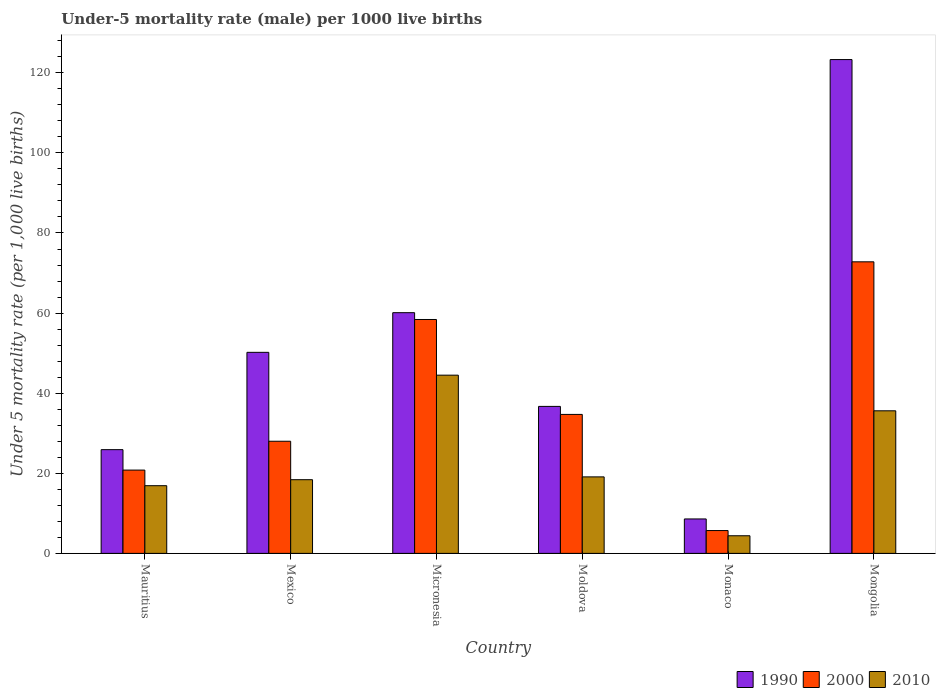Are the number of bars per tick equal to the number of legend labels?
Keep it short and to the point. Yes. How many bars are there on the 6th tick from the left?
Make the answer very short. 3. What is the label of the 4th group of bars from the left?
Give a very brief answer. Moldova. What is the under-five mortality rate in 1990 in Mongolia?
Give a very brief answer. 123.3. Across all countries, what is the maximum under-five mortality rate in 2000?
Provide a succinct answer. 72.8. In which country was the under-five mortality rate in 2010 maximum?
Make the answer very short. Micronesia. In which country was the under-five mortality rate in 2010 minimum?
Provide a short and direct response. Monaco. What is the total under-five mortality rate in 1990 in the graph?
Give a very brief answer. 304.8. What is the difference between the under-five mortality rate in 2010 in Mauritius and that in Monaco?
Provide a succinct answer. 12.5. What is the difference between the under-five mortality rate in 2000 in Mexico and the under-five mortality rate in 2010 in Micronesia?
Your response must be concise. -16.5. What is the average under-five mortality rate in 2000 per country?
Your response must be concise. 36.73. What is the difference between the under-five mortality rate of/in 2000 and under-five mortality rate of/in 2010 in Mexico?
Your response must be concise. 9.6. What is the ratio of the under-five mortality rate in 1990 in Mauritius to that in Mexico?
Provide a short and direct response. 0.52. Is the under-five mortality rate in 2010 in Mauritius less than that in Moldova?
Keep it short and to the point. Yes. Is the difference between the under-five mortality rate in 2000 in Mexico and Moldova greater than the difference between the under-five mortality rate in 2010 in Mexico and Moldova?
Your response must be concise. No. What is the difference between the highest and the second highest under-five mortality rate in 2000?
Offer a very short reply. 14.4. What is the difference between the highest and the lowest under-five mortality rate in 2010?
Offer a very short reply. 40.1. What does the 3rd bar from the right in Mongolia represents?
Keep it short and to the point. 1990. How many bars are there?
Your response must be concise. 18. How many countries are there in the graph?
Provide a short and direct response. 6. Are the values on the major ticks of Y-axis written in scientific E-notation?
Ensure brevity in your answer.  No. Does the graph contain any zero values?
Your answer should be very brief. No. Does the graph contain grids?
Give a very brief answer. No. How are the legend labels stacked?
Provide a short and direct response. Horizontal. What is the title of the graph?
Your answer should be very brief. Under-5 mortality rate (male) per 1000 live births. Does "2010" appear as one of the legend labels in the graph?
Offer a very short reply. Yes. What is the label or title of the X-axis?
Offer a terse response. Country. What is the label or title of the Y-axis?
Keep it short and to the point. Under 5 mortality rate (per 1,0 live births). What is the Under 5 mortality rate (per 1,000 live births) in 1990 in Mauritius?
Make the answer very short. 25.9. What is the Under 5 mortality rate (per 1,000 live births) of 2000 in Mauritius?
Provide a succinct answer. 20.8. What is the Under 5 mortality rate (per 1,000 live births) in 1990 in Mexico?
Offer a very short reply. 50.2. What is the Under 5 mortality rate (per 1,000 live births) of 1990 in Micronesia?
Your answer should be very brief. 60.1. What is the Under 5 mortality rate (per 1,000 live births) in 2000 in Micronesia?
Your answer should be very brief. 58.4. What is the Under 5 mortality rate (per 1,000 live births) of 2010 in Micronesia?
Give a very brief answer. 44.5. What is the Under 5 mortality rate (per 1,000 live births) of 1990 in Moldova?
Offer a terse response. 36.7. What is the Under 5 mortality rate (per 1,000 live births) of 2000 in Moldova?
Ensure brevity in your answer.  34.7. What is the Under 5 mortality rate (per 1,000 live births) of 1990 in Monaco?
Give a very brief answer. 8.6. What is the Under 5 mortality rate (per 1,000 live births) in 2000 in Monaco?
Ensure brevity in your answer.  5.7. What is the Under 5 mortality rate (per 1,000 live births) of 2010 in Monaco?
Ensure brevity in your answer.  4.4. What is the Under 5 mortality rate (per 1,000 live births) in 1990 in Mongolia?
Provide a short and direct response. 123.3. What is the Under 5 mortality rate (per 1,000 live births) in 2000 in Mongolia?
Make the answer very short. 72.8. What is the Under 5 mortality rate (per 1,000 live births) in 2010 in Mongolia?
Give a very brief answer. 35.6. Across all countries, what is the maximum Under 5 mortality rate (per 1,000 live births) of 1990?
Your answer should be very brief. 123.3. Across all countries, what is the maximum Under 5 mortality rate (per 1,000 live births) of 2000?
Your response must be concise. 72.8. Across all countries, what is the maximum Under 5 mortality rate (per 1,000 live births) in 2010?
Make the answer very short. 44.5. Across all countries, what is the minimum Under 5 mortality rate (per 1,000 live births) of 1990?
Provide a succinct answer. 8.6. Across all countries, what is the minimum Under 5 mortality rate (per 1,000 live births) in 2000?
Your response must be concise. 5.7. What is the total Under 5 mortality rate (per 1,000 live births) of 1990 in the graph?
Provide a short and direct response. 304.8. What is the total Under 5 mortality rate (per 1,000 live births) in 2000 in the graph?
Offer a very short reply. 220.4. What is the total Under 5 mortality rate (per 1,000 live births) of 2010 in the graph?
Provide a succinct answer. 138.9. What is the difference between the Under 5 mortality rate (per 1,000 live births) of 1990 in Mauritius and that in Mexico?
Your answer should be compact. -24.3. What is the difference between the Under 5 mortality rate (per 1,000 live births) in 2000 in Mauritius and that in Mexico?
Give a very brief answer. -7.2. What is the difference between the Under 5 mortality rate (per 1,000 live births) of 1990 in Mauritius and that in Micronesia?
Your answer should be very brief. -34.2. What is the difference between the Under 5 mortality rate (per 1,000 live births) in 2000 in Mauritius and that in Micronesia?
Your answer should be compact. -37.6. What is the difference between the Under 5 mortality rate (per 1,000 live births) of 2010 in Mauritius and that in Micronesia?
Keep it short and to the point. -27.6. What is the difference between the Under 5 mortality rate (per 1,000 live births) of 1990 in Mauritius and that in Moldova?
Your answer should be very brief. -10.8. What is the difference between the Under 5 mortality rate (per 1,000 live births) of 2010 in Mauritius and that in Moldova?
Your answer should be compact. -2.2. What is the difference between the Under 5 mortality rate (per 1,000 live births) in 1990 in Mauritius and that in Mongolia?
Provide a short and direct response. -97.4. What is the difference between the Under 5 mortality rate (per 1,000 live births) in 2000 in Mauritius and that in Mongolia?
Offer a terse response. -52. What is the difference between the Under 5 mortality rate (per 1,000 live births) in 2010 in Mauritius and that in Mongolia?
Provide a succinct answer. -18.7. What is the difference between the Under 5 mortality rate (per 1,000 live births) of 2000 in Mexico and that in Micronesia?
Make the answer very short. -30.4. What is the difference between the Under 5 mortality rate (per 1,000 live births) in 2010 in Mexico and that in Micronesia?
Your answer should be compact. -26.1. What is the difference between the Under 5 mortality rate (per 1,000 live births) of 2000 in Mexico and that in Moldova?
Make the answer very short. -6.7. What is the difference between the Under 5 mortality rate (per 1,000 live births) in 2010 in Mexico and that in Moldova?
Provide a succinct answer. -0.7. What is the difference between the Under 5 mortality rate (per 1,000 live births) of 1990 in Mexico and that in Monaco?
Your answer should be compact. 41.6. What is the difference between the Under 5 mortality rate (per 1,000 live births) of 2000 in Mexico and that in Monaco?
Ensure brevity in your answer.  22.3. What is the difference between the Under 5 mortality rate (per 1,000 live births) of 1990 in Mexico and that in Mongolia?
Give a very brief answer. -73.1. What is the difference between the Under 5 mortality rate (per 1,000 live births) of 2000 in Mexico and that in Mongolia?
Make the answer very short. -44.8. What is the difference between the Under 5 mortality rate (per 1,000 live births) in 2010 in Mexico and that in Mongolia?
Keep it short and to the point. -17.2. What is the difference between the Under 5 mortality rate (per 1,000 live births) in 1990 in Micronesia and that in Moldova?
Give a very brief answer. 23.4. What is the difference between the Under 5 mortality rate (per 1,000 live births) in 2000 in Micronesia and that in Moldova?
Give a very brief answer. 23.7. What is the difference between the Under 5 mortality rate (per 1,000 live births) of 2010 in Micronesia and that in Moldova?
Provide a short and direct response. 25.4. What is the difference between the Under 5 mortality rate (per 1,000 live births) of 1990 in Micronesia and that in Monaco?
Your response must be concise. 51.5. What is the difference between the Under 5 mortality rate (per 1,000 live births) in 2000 in Micronesia and that in Monaco?
Make the answer very short. 52.7. What is the difference between the Under 5 mortality rate (per 1,000 live births) of 2010 in Micronesia and that in Monaco?
Your response must be concise. 40.1. What is the difference between the Under 5 mortality rate (per 1,000 live births) in 1990 in Micronesia and that in Mongolia?
Your answer should be compact. -63.2. What is the difference between the Under 5 mortality rate (per 1,000 live births) in 2000 in Micronesia and that in Mongolia?
Keep it short and to the point. -14.4. What is the difference between the Under 5 mortality rate (per 1,000 live births) of 2010 in Micronesia and that in Mongolia?
Offer a very short reply. 8.9. What is the difference between the Under 5 mortality rate (per 1,000 live births) of 1990 in Moldova and that in Monaco?
Provide a short and direct response. 28.1. What is the difference between the Under 5 mortality rate (per 1,000 live births) in 1990 in Moldova and that in Mongolia?
Your response must be concise. -86.6. What is the difference between the Under 5 mortality rate (per 1,000 live births) of 2000 in Moldova and that in Mongolia?
Make the answer very short. -38.1. What is the difference between the Under 5 mortality rate (per 1,000 live births) of 2010 in Moldova and that in Mongolia?
Your response must be concise. -16.5. What is the difference between the Under 5 mortality rate (per 1,000 live births) of 1990 in Monaco and that in Mongolia?
Give a very brief answer. -114.7. What is the difference between the Under 5 mortality rate (per 1,000 live births) in 2000 in Monaco and that in Mongolia?
Offer a very short reply. -67.1. What is the difference between the Under 5 mortality rate (per 1,000 live births) in 2010 in Monaco and that in Mongolia?
Provide a short and direct response. -31.2. What is the difference between the Under 5 mortality rate (per 1,000 live births) in 1990 in Mauritius and the Under 5 mortality rate (per 1,000 live births) in 2000 in Mexico?
Provide a succinct answer. -2.1. What is the difference between the Under 5 mortality rate (per 1,000 live births) of 1990 in Mauritius and the Under 5 mortality rate (per 1,000 live births) of 2010 in Mexico?
Provide a succinct answer. 7.5. What is the difference between the Under 5 mortality rate (per 1,000 live births) of 2000 in Mauritius and the Under 5 mortality rate (per 1,000 live births) of 2010 in Mexico?
Give a very brief answer. 2.4. What is the difference between the Under 5 mortality rate (per 1,000 live births) of 1990 in Mauritius and the Under 5 mortality rate (per 1,000 live births) of 2000 in Micronesia?
Keep it short and to the point. -32.5. What is the difference between the Under 5 mortality rate (per 1,000 live births) in 1990 in Mauritius and the Under 5 mortality rate (per 1,000 live births) in 2010 in Micronesia?
Give a very brief answer. -18.6. What is the difference between the Under 5 mortality rate (per 1,000 live births) in 2000 in Mauritius and the Under 5 mortality rate (per 1,000 live births) in 2010 in Micronesia?
Ensure brevity in your answer.  -23.7. What is the difference between the Under 5 mortality rate (per 1,000 live births) of 1990 in Mauritius and the Under 5 mortality rate (per 1,000 live births) of 2000 in Moldova?
Give a very brief answer. -8.8. What is the difference between the Under 5 mortality rate (per 1,000 live births) in 1990 in Mauritius and the Under 5 mortality rate (per 1,000 live births) in 2000 in Monaco?
Provide a succinct answer. 20.2. What is the difference between the Under 5 mortality rate (per 1,000 live births) in 1990 in Mauritius and the Under 5 mortality rate (per 1,000 live births) in 2010 in Monaco?
Offer a terse response. 21.5. What is the difference between the Under 5 mortality rate (per 1,000 live births) of 1990 in Mauritius and the Under 5 mortality rate (per 1,000 live births) of 2000 in Mongolia?
Keep it short and to the point. -46.9. What is the difference between the Under 5 mortality rate (per 1,000 live births) of 1990 in Mauritius and the Under 5 mortality rate (per 1,000 live births) of 2010 in Mongolia?
Offer a terse response. -9.7. What is the difference between the Under 5 mortality rate (per 1,000 live births) of 2000 in Mauritius and the Under 5 mortality rate (per 1,000 live births) of 2010 in Mongolia?
Provide a succinct answer. -14.8. What is the difference between the Under 5 mortality rate (per 1,000 live births) in 2000 in Mexico and the Under 5 mortality rate (per 1,000 live births) in 2010 in Micronesia?
Provide a short and direct response. -16.5. What is the difference between the Under 5 mortality rate (per 1,000 live births) in 1990 in Mexico and the Under 5 mortality rate (per 1,000 live births) in 2010 in Moldova?
Offer a very short reply. 31.1. What is the difference between the Under 5 mortality rate (per 1,000 live births) of 1990 in Mexico and the Under 5 mortality rate (per 1,000 live births) of 2000 in Monaco?
Make the answer very short. 44.5. What is the difference between the Under 5 mortality rate (per 1,000 live births) in 1990 in Mexico and the Under 5 mortality rate (per 1,000 live births) in 2010 in Monaco?
Offer a very short reply. 45.8. What is the difference between the Under 5 mortality rate (per 1,000 live births) in 2000 in Mexico and the Under 5 mortality rate (per 1,000 live births) in 2010 in Monaco?
Ensure brevity in your answer.  23.6. What is the difference between the Under 5 mortality rate (per 1,000 live births) of 1990 in Mexico and the Under 5 mortality rate (per 1,000 live births) of 2000 in Mongolia?
Give a very brief answer. -22.6. What is the difference between the Under 5 mortality rate (per 1,000 live births) of 2000 in Mexico and the Under 5 mortality rate (per 1,000 live births) of 2010 in Mongolia?
Make the answer very short. -7.6. What is the difference between the Under 5 mortality rate (per 1,000 live births) of 1990 in Micronesia and the Under 5 mortality rate (per 1,000 live births) of 2000 in Moldova?
Your answer should be compact. 25.4. What is the difference between the Under 5 mortality rate (per 1,000 live births) of 2000 in Micronesia and the Under 5 mortality rate (per 1,000 live births) of 2010 in Moldova?
Give a very brief answer. 39.3. What is the difference between the Under 5 mortality rate (per 1,000 live births) of 1990 in Micronesia and the Under 5 mortality rate (per 1,000 live births) of 2000 in Monaco?
Your response must be concise. 54.4. What is the difference between the Under 5 mortality rate (per 1,000 live births) in 1990 in Micronesia and the Under 5 mortality rate (per 1,000 live births) in 2010 in Monaco?
Provide a short and direct response. 55.7. What is the difference between the Under 5 mortality rate (per 1,000 live births) in 1990 in Micronesia and the Under 5 mortality rate (per 1,000 live births) in 2000 in Mongolia?
Provide a succinct answer. -12.7. What is the difference between the Under 5 mortality rate (per 1,000 live births) in 2000 in Micronesia and the Under 5 mortality rate (per 1,000 live births) in 2010 in Mongolia?
Ensure brevity in your answer.  22.8. What is the difference between the Under 5 mortality rate (per 1,000 live births) in 1990 in Moldova and the Under 5 mortality rate (per 1,000 live births) in 2010 in Monaco?
Offer a terse response. 32.3. What is the difference between the Under 5 mortality rate (per 1,000 live births) of 2000 in Moldova and the Under 5 mortality rate (per 1,000 live births) of 2010 in Monaco?
Your answer should be very brief. 30.3. What is the difference between the Under 5 mortality rate (per 1,000 live births) of 1990 in Moldova and the Under 5 mortality rate (per 1,000 live births) of 2000 in Mongolia?
Ensure brevity in your answer.  -36.1. What is the difference between the Under 5 mortality rate (per 1,000 live births) in 1990 in Moldova and the Under 5 mortality rate (per 1,000 live births) in 2010 in Mongolia?
Your answer should be compact. 1.1. What is the difference between the Under 5 mortality rate (per 1,000 live births) in 1990 in Monaco and the Under 5 mortality rate (per 1,000 live births) in 2000 in Mongolia?
Your response must be concise. -64.2. What is the difference between the Under 5 mortality rate (per 1,000 live births) in 2000 in Monaco and the Under 5 mortality rate (per 1,000 live births) in 2010 in Mongolia?
Offer a very short reply. -29.9. What is the average Under 5 mortality rate (per 1,000 live births) of 1990 per country?
Give a very brief answer. 50.8. What is the average Under 5 mortality rate (per 1,000 live births) of 2000 per country?
Offer a terse response. 36.73. What is the average Under 5 mortality rate (per 1,000 live births) in 2010 per country?
Provide a succinct answer. 23.15. What is the difference between the Under 5 mortality rate (per 1,000 live births) in 2000 and Under 5 mortality rate (per 1,000 live births) in 2010 in Mauritius?
Ensure brevity in your answer.  3.9. What is the difference between the Under 5 mortality rate (per 1,000 live births) in 1990 and Under 5 mortality rate (per 1,000 live births) in 2000 in Mexico?
Ensure brevity in your answer.  22.2. What is the difference between the Under 5 mortality rate (per 1,000 live births) of 1990 and Under 5 mortality rate (per 1,000 live births) of 2010 in Mexico?
Make the answer very short. 31.8. What is the difference between the Under 5 mortality rate (per 1,000 live births) in 2000 and Under 5 mortality rate (per 1,000 live births) in 2010 in Micronesia?
Provide a short and direct response. 13.9. What is the difference between the Under 5 mortality rate (per 1,000 live births) of 1990 and Under 5 mortality rate (per 1,000 live births) of 2000 in Moldova?
Offer a terse response. 2. What is the difference between the Under 5 mortality rate (per 1,000 live births) in 1990 and Under 5 mortality rate (per 1,000 live births) in 2010 in Moldova?
Your answer should be compact. 17.6. What is the difference between the Under 5 mortality rate (per 1,000 live births) of 1990 and Under 5 mortality rate (per 1,000 live births) of 2010 in Monaco?
Offer a very short reply. 4.2. What is the difference between the Under 5 mortality rate (per 1,000 live births) in 2000 and Under 5 mortality rate (per 1,000 live births) in 2010 in Monaco?
Provide a short and direct response. 1.3. What is the difference between the Under 5 mortality rate (per 1,000 live births) of 1990 and Under 5 mortality rate (per 1,000 live births) of 2000 in Mongolia?
Offer a terse response. 50.5. What is the difference between the Under 5 mortality rate (per 1,000 live births) of 1990 and Under 5 mortality rate (per 1,000 live births) of 2010 in Mongolia?
Provide a succinct answer. 87.7. What is the difference between the Under 5 mortality rate (per 1,000 live births) of 2000 and Under 5 mortality rate (per 1,000 live births) of 2010 in Mongolia?
Your answer should be compact. 37.2. What is the ratio of the Under 5 mortality rate (per 1,000 live births) of 1990 in Mauritius to that in Mexico?
Your response must be concise. 0.52. What is the ratio of the Under 5 mortality rate (per 1,000 live births) of 2000 in Mauritius to that in Mexico?
Provide a succinct answer. 0.74. What is the ratio of the Under 5 mortality rate (per 1,000 live births) of 2010 in Mauritius to that in Mexico?
Your answer should be very brief. 0.92. What is the ratio of the Under 5 mortality rate (per 1,000 live births) of 1990 in Mauritius to that in Micronesia?
Your answer should be compact. 0.43. What is the ratio of the Under 5 mortality rate (per 1,000 live births) in 2000 in Mauritius to that in Micronesia?
Provide a succinct answer. 0.36. What is the ratio of the Under 5 mortality rate (per 1,000 live births) in 2010 in Mauritius to that in Micronesia?
Provide a short and direct response. 0.38. What is the ratio of the Under 5 mortality rate (per 1,000 live births) of 1990 in Mauritius to that in Moldova?
Your response must be concise. 0.71. What is the ratio of the Under 5 mortality rate (per 1,000 live births) of 2000 in Mauritius to that in Moldova?
Your response must be concise. 0.6. What is the ratio of the Under 5 mortality rate (per 1,000 live births) of 2010 in Mauritius to that in Moldova?
Offer a very short reply. 0.88. What is the ratio of the Under 5 mortality rate (per 1,000 live births) of 1990 in Mauritius to that in Monaco?
Offer a terse response. 3.01. What is the ratio of the Under 5 mortality rate (per 1,000 live births) of 2000 in Mauritius to that in Monaco?
Keep it short and to the point. 3.65. What is the ratio of the Under 5 mortality rate (per 1,000 live births) in 2010 in Mauritius to that in Monaco?
Keep it short and to the point. 3.84. What is the ratio of the Under 5 mortality rate (per 1,000 live births) in 1990 in Mauritius to that in Mongolia?
Provide a succinct answer. 0.21. What is the ratio of the Under 5 mortality rate (per 1,000 live births) of 2000 in Mauritius to that in Mongolia?
Offer a terse response. 0.29. What is the ratio of the Under 5 mortality rate (per 1,000 live births) in 2010 in Mauritius to that in Mongolia?
Your answer should be compact. 0.47. What is the ratio of the Under 5 mortality rate (per 1,000 live births) of 1990 in Mexico to that in Micronesia?
Your answer should be compact. 0.84. What is the ratio of the Under 5 mortality rate (per 1,000 live births) of 2000 in Mexico to that in Micronesia?
Ensure brevity in your answer.  0.48. What is the ratio of the Under 5 mortality rate (per 1,000 live births) in 2010 in Mexico to that in Micronesia?
Offer a very short reply. 0.41. What is the ratio of the Under 5 mortality rate (per 1,000 live births) in 1990 in Mexico to that in Moldova?
Offer a terse response. 1.37. What is the ratio of the Under 5 mortality rate (per 1,000 live births) in 2000 in Mexico to that in Moldova?
Your answer should be very brief. 0.81. What is the ratio of the Under 5 mortality rate (per 1,000 live births) of 2010 in Mexico to that in Moldova?
Offer a terse response. 0.96. What is the ratio of the Under 5 mortality rate (per 1,000 live births) of 1990 in Mexico to that in Monaco?
Your answer should be very brief. 5.84. What is the ratio of the Under 5 mortality rate (per 1,000 live births) in 2000 in Mexico to that in Monaco?
Your answer should be very brief. 4.91. What is the ratio of the Under 5 mortality rate (per 1,000 live births) of 2010 in Mexico to that in Monaco?
Your answer should be compact. 4.18. What is the ratio of the Under 5 mortality rate (per 1,000 live births) of 1990 in Mexico to that in Mongolia?
Your answer should be very brief. 0.41. What is the ratio of the Under 5 mortality rate (per 1,000 live births) in 2000 in Mexico to that in Mongolia?
Offer a terse response. 0.38. What is the ratio of the Under 5 mortality rate (per 1,000 live births) in 2010 in Mexico to that in Mongolia?
Make the answer very short. 0.52. What is the ratio of the Under 5 mortality rate (per 1,000 live births) of 1990 in Micronesia to that in Moldova?
Your answer should be compact. 1.64. What is the ratio of the Under 5 mortality rate (per 1,000 live births) of 2000 in Micronesia to that in Moldova?
Give a very brief answer. 1.68. What is the ratio of the Under 5 mortality rate (per 1,000 live births) in 2010 in Micronesia to that in Moldova?
Provide a succinct answer. 2.33. What is the ratio of the Under 5 mortality rate (per 1,000 live births) of 1990 in Micronesia to that in Monaco?
Offer a very short reply. 6.99. What is the ratio of the Under 5 mortality rate (per 1,000 live births) in 2000 in Micronesia to that in Monaco?
Your answer should be very brief. 10.25. What is the ratio of the Under 5 mortality rate (per 1,000 live births) in 2010 in Micronesia to that in Monaco?
Your response must be concise. 10.11. What is the ratio of the Under 5 mortality rate (per 1,000 live births) in 1990 in Micronesia to that in Mongolia?
Offer a terse response. 0.49. What is the ratio of the Under 5 mortality rate (per 1,000 live births) of 2000 in Micronesia to that in Mongolia?
Ensure brevity in your answer.  0.8. What is the ratio of the Under 5 mortality rate (per 1,000 live births) of 2010 in Micronesia to that in Mongolia?
Your answer should be very brief. 1.25. What is the ratio of the Under 5 mortality rate (per 1,000 live births) of 1990 in Moldova to that in Monaco?
Your response must be concise. 4.27. What is the ratio of the Under 5 mortality rate (per 1,000 live births) of 2000 in Moldova to that in Monaco?
Keep it short and to the point. 6.09. What is the ratio of the Under 5 mortality rate (per 1,000 live births) of 2010 in Moldova to that in Monaco?
Provide a short and direct response. 4.34. What is the ratio of the Under 5 mortality rate (per 1,000 live births) in 1990 in Moldova to that in Mongolia?
Keep it short and to the point. 0.3. What is the ratio of the Under 5 mortality rate (per 1,000 live births) in 2000 in Moldova to that in Mongolia?
Provide a short and direct response. 0.48. What is the ratio of the Under 5 mortality rate (per 1,000 live births) in 2010 in Moldova to that in Mongolia?
Offer a very short reply. 0.54. What is the ratio of the Under 5 mortality rate (per 1,000 live births) of 1990 in Monaco to that in Mongolia?
Offer a very short reply. 0.07. What is the ratio of the Under 5 mortality rate (per 1,000 live births) in 2000 in Monaco to that in Mongolia?
Offer a terse response. 0.08. What is the ratio of the Under 5 mortality rate (per 1,000 live births) of 2010 in Monaco to that in Mongolia?
Your response must be concise. 0.12. What is the difference between the highest and the second highest Under 5 mortality rate (per 1,000 live births) in 1990?
Make the answer very short. 63.2. What is the difference between the highest and the second highest Under 5 mortality rate (per 1,000 live births) in 2010?
Offer a very short reply. 8.9. What is the difference between the highest and the lowest Under 5 mortality rate (per 1,000 live births) of 1990?
Offer a terse response. 114.7. What is the difference between the highest and the lowest Under 5 mortality rate (per 1,000 live births) in 2000?
Offer a very short reply. 67.1. What is the difference between the highest and the lowest Under 5 mortality rate (per 1,000 live births) of 2010?
Make the answer very short. 40.1. 